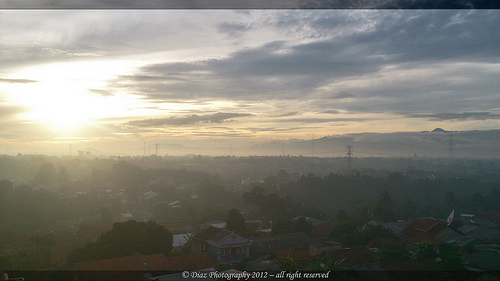<image>
Is there a sunshine under the cloud? Yes. The sunshine is positioned underneath the cloud, with the cloud above it in the vertical space. 